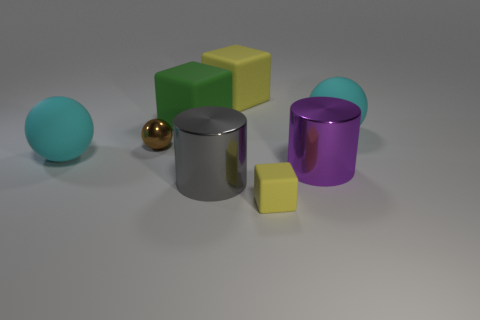Subtract all large green cubes. How many cubes are left? 2 Subtract all green blocks. How many blocks are left? 2 Subtract all blocks. How many objects are left? 5 Subtract all tiny yellow cylinders. Subtract all big gray things. How many objects are left? 7 Add 4 large gray objects. How many large gray objects are left? 5 Add 3 spheres. How many spheres exist? 6 Add 2 tiny shiny spheres. How many objects exist? 10 Subtract 1 gray cylinders. How many objects are left? 7 Subtract 1 cylinders. How many cylinders are left? 1 Subtract all yellow spheres. Subtract all gray cylinders. How many spheres are left? 3 